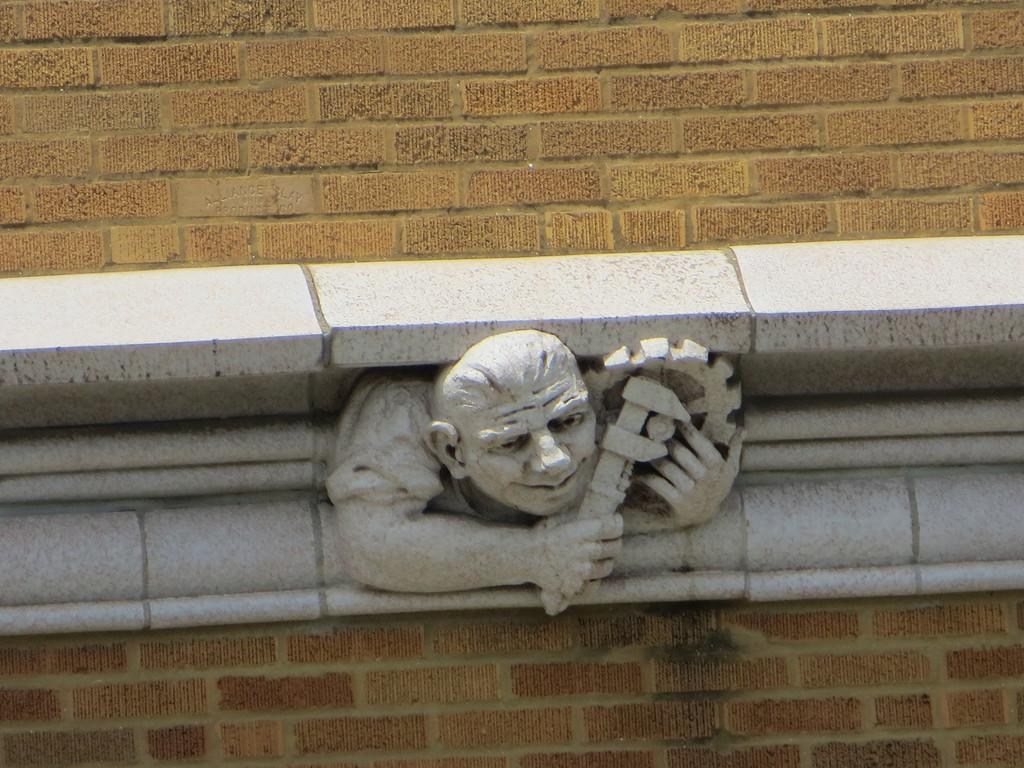What is the main subject of the picture? The main subject of the picture is a sculpture. Can you describe the sculpture? The sculpture is of a person. Where is the sculpture located? The sculpture is on a brick wall. What type of flag is being waved by the person in the sculpture? There is no flag present in the image, as the main subject is a sculpture of a person on a brick wall. 